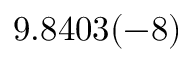<formula> <loc_0><loc_0><loc_500><loc_500>9 . 8 4 0 3 ( - 8 )</formula> 